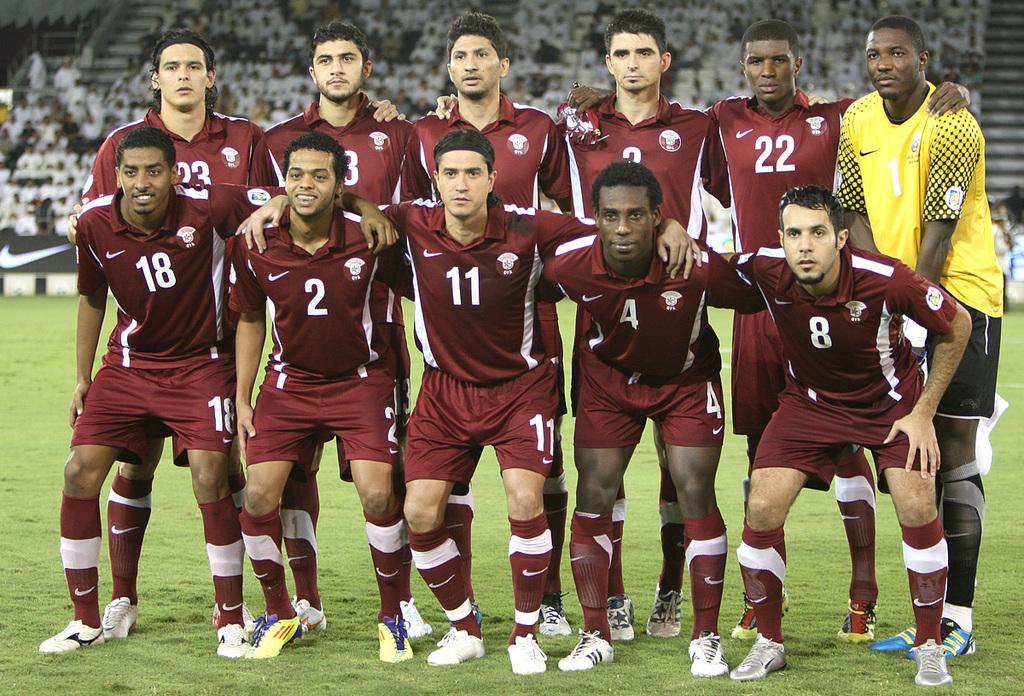<image>
Offer a succinct explanation of the picture presented. The player in the yellow jersey is wearing number 1 